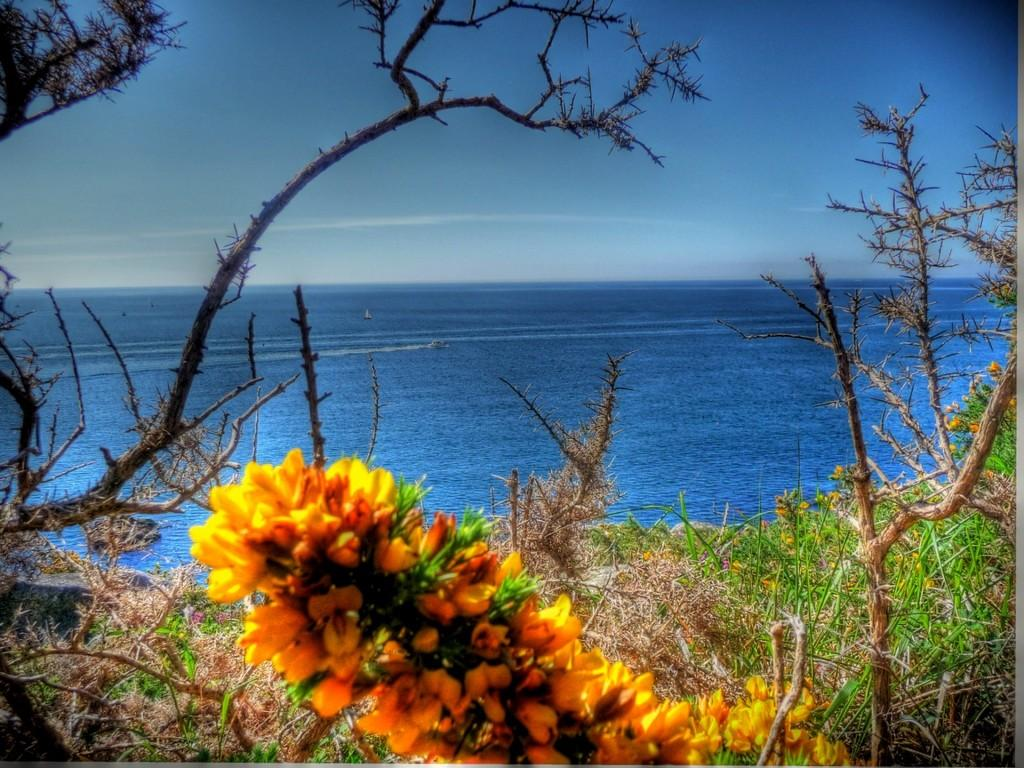What type of vegetation can be seen in the image? There are trees and flowers in the image. What can be seen in the background of the image? There is water and the sky visible in the background of the image. What type of wrench is being used to pick the apples in the image? There are no apples or wrenches present in the image. What place is depicted in the image? The image does not depict a specific place; it features trees, flowers, water, and the sky. 